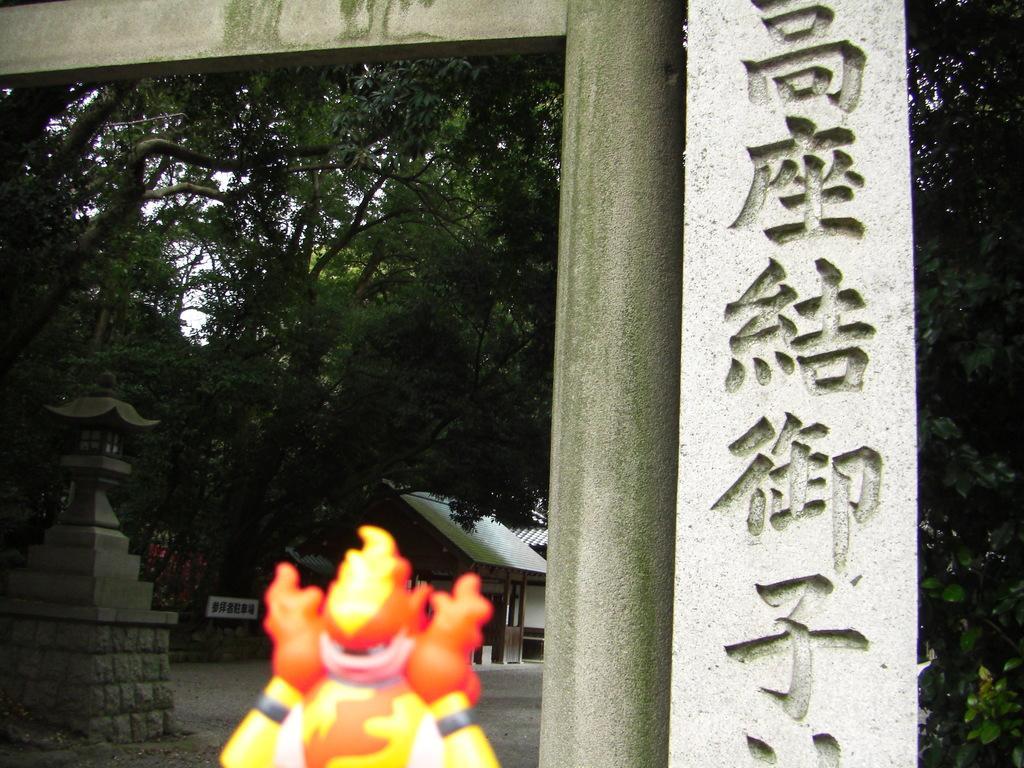Could you give a brief overview of what you see in this image? In this image we can see many trees in the image. There is a stone pillar in the image. There is an object which in color of orange, yellow and white. 